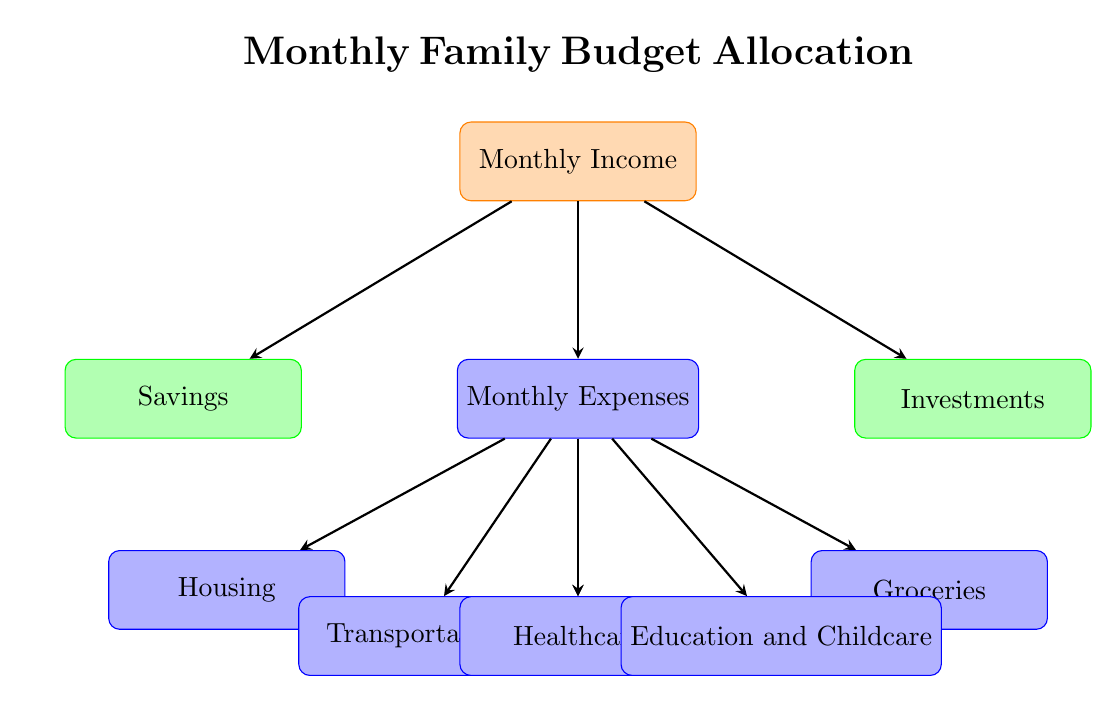What is the starting point of the flow chart? The starting point of the flow chart is labeled "Monthly Income", which is the source node at the top of the diagram. This is where the budget allocation process begins.
Answer: Monthly Income How many main expense categories are shown in the diagram? The diagram presents six main expense categories that stem from the "Monthly Expenses" node: Housing, Utilities, Groceries, Transportation, Healthcare, and Education and Childcare. Counting these gives us a total of six categories.
Answer: Six Which node represents future financial growth? The node labeled "Investments" indicates future financial growth in the budget allocation, suggesting that a portion of income will be directed toward growing assets or savings for the future.
Answer: Investments What financial category comes immediately after "Monthly Income"? Immediately following "Monthly Income," the next node is "Monthly Expenses," indicating that once income is received, it is allocated to monthly expenses.
Answer: Monthly Expenses Which expense category is associated with housing needs? The "Housing" category is directly associated with essential housing needs like rent or mortgage payments and is one of the main expense categories branching from "Monthly Expenses."
Answer: Housing If all income is directed towards savings, what happens to expenses in the diagram? In the scenario where all income is directed towards savings, it implies that there would be no allocation to "Monthly Expenses," meaning expenses would not be covered. Essentially, the flow diagram indicates that you cannot allocate income to expenses if it is entirely allocated to savings.
Answer: Expenses go unallocated How many nodes lead away from "Monthly Expenses"? From "Monthly Expenses," there are six nodes leading away, which represent the specific categories of expenses: Housing, Utilities, Groceries, Transportation, Healthcare, and Education and Childcare, clearly identified in the diagram.
Answer: Six Which process node comes first when looking at expenses? The first process node that emerges from the "Monthly Expenses" node is "Housing," indicating it is likely prioritized as a necessary expense.
Answer: Housing 